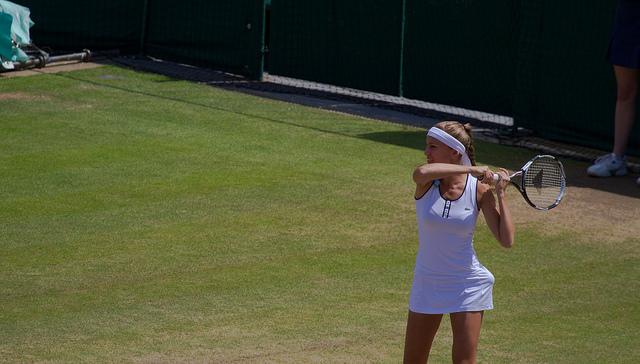What sport is this?
Be succinct. Tennis. Is this woman playing in a park?
Give a very brief answer. No. What does the woman have around her head?
Answer briefly. Headband. What is the court composed of?
Concise answer only. Grass. What sport is the woman playing?
Be succinct. Tennis. What is sticking out of the side of her pocket?
Short answer required. Ball. Is she trying to get network?
Quick response, please. No. 